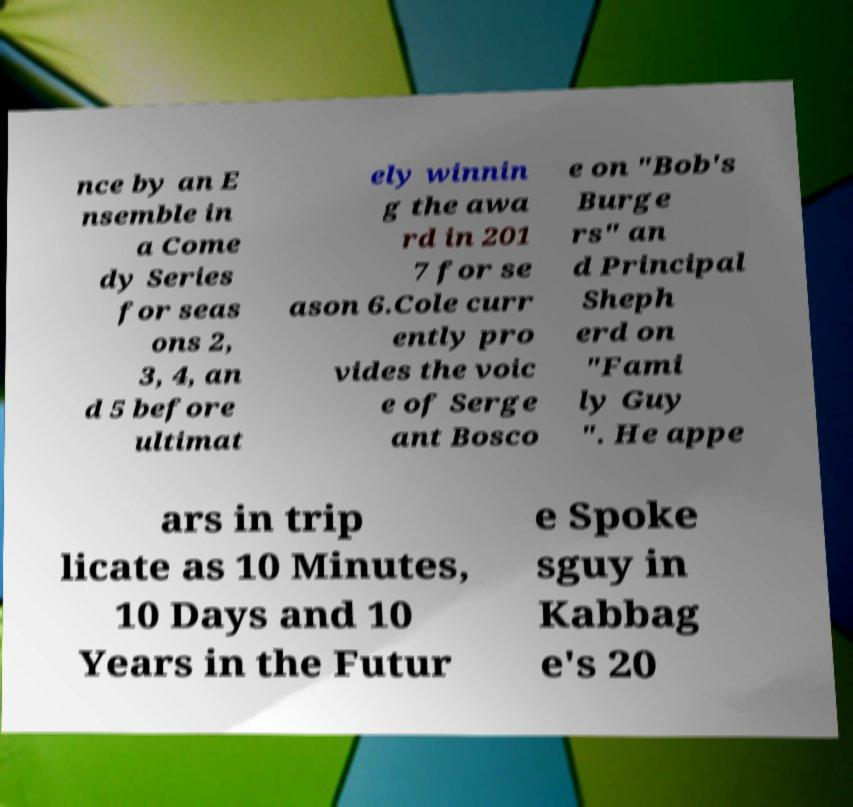Please read and relay the text visible in this image. What does it say? nce by an E nsemble in a Come dy Series for seas ons 2, 3, 4, an d 5 before ultimat ely winnin g the awa rd in 201 7 for se ason 6.Cole curr ently pro vides the voic e of Serge ant Bosco e on "Bob's Burge rs" an d Principal Sheph erd on "Fami ly Guy ". He appe ars in trip licate as 10 Minutes, 10 Days and 10 Years in the Futur e Spoke sguy in Kabbag e's 20 